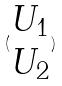<formula> <loc_0><loc_0><loc_500><loc_500>( \begin{matrix} U _ { 1 } \\ U _ { 2 } \end{matrix} )</formula> 